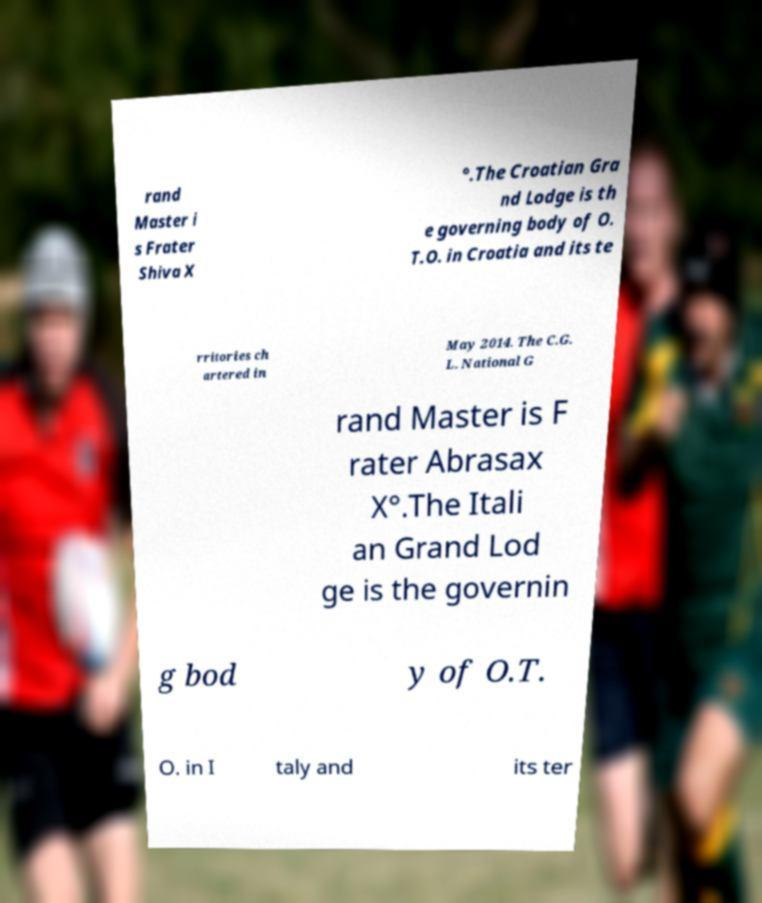Could you extract and type out the text from this image? rand Master i s Frater Shiva X °.The Croatian Gra nd Lodge is th e governing body of O. T.O. in Croatia and its te rritories ch artered in May 2014. The C.G. L. National G rand Master is F rater Abrasax X°.The Itali an Grand Lod ge is the governin g bod y of O.T. O. in I taly and its ter 